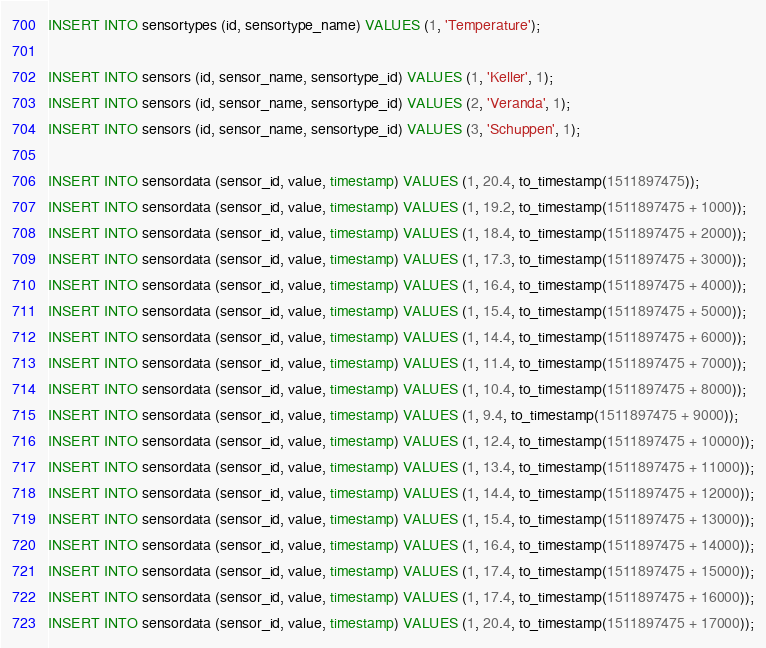<code> <loc_0><loc_0><loc_500><loc_500><_SQL_>INSERT INTO sensortypes (id, sensortype_name) VALUES (1, 'Temperature');

INSERT INTO sensors (id, sensor_name, sensortype_id) VALUES (1, 'Keller', 1);
INSERT INTO sensors (id, sensor_name, sensortype_id) VALUES (2, 'Veranda', 1);
INSERT INTO sensors (id, sensor_name, sensortype_id) VALUES (3, 'Schuppen', 1);

INSERT INTO sensordata (sensor_id, value, timestamp) VALUES (1, 20.4, to_timestamp(1511897475));
INSERT INTO sensordata (sensor_id, value, timestamp) VALUES (1, 19.2, to_timestamp(1511897475 + 1000));
INSERT INTO sensordata (sensor_id, value, timestamp) VALUES (1, 18.4, to_timestamp(1511897475 + 2000));
INSERT INTO sensordata (sensor_id, value, timestamp) VALUES (1, 17.3, to_timestamp(1511897475 + 3000));
INSERT INTO sensordata (sensor_id, value, timestamp) VALUES (1, 16.4, to_timestamp(1511897475 + 4000));
INSERT INTO sensordata (sensor_id, value, timestamp) VALUES (1, 15.4, to_timestamp(1511897475 + 5000));
INSERT INTO sensordata (sensor_id, value, timestamp) VALUES (1, 14.4, to_timestamp(1511897475 + 6000));
INSERT INTO sensordata (sensor_id, value, timestamp) VALUES (1, 11.4, to_timestamp(1511897475 + 7000));
INSERT INTO sensordata (sensor_id, value, timestamp) VALUES (1, 10.4, to_timestamp(1511897475 + 8000));
INSERT INTO sensordata (sensor_id, value, timestamp) VALUES (1, 9.4, to_timestamp(1511897475 + 9000));
INSERT INTO sensordata (sensor_id, value, timestamp) VALUES (1, 12.4, to_timestamp(1511897475 + 10000));
INSERT INTO sensordata (sensor_id, value, timestamp) VALUES (1, 13.4, to_timestamp(1511897475 + 11000));
INSERT INTO sensordata (sensor_id, value, timestamp) VALUES (1, 14.4, to_timestamp(1511897475 + 12000));
INSERT INTO sensordata (sensor_id, value, timestamp) VALUES (1, 15.4, to_timestamp(1511897475 + 13000));
INSERT INTO sensordata (sensor_id, value, timestamp) VALUES (1, 16.4, to_timestamp(1511897475 + 14000));
INSERT INTO sensordata (sensor_id, value, timestamp) VALUES (1, 17.4, to_timestamp(1511897475 + 15000));
INSERT INTO sensordata (sensor_id, value, timestamp) VALUES (1, 17.4, to_timestamp(1511897475 + 16000));
INSERT INTO sensordata (sensor_id, value, timestamp) VALUES (1, 20.4, to_timestamp(1511897475 + 17000));
</code> 